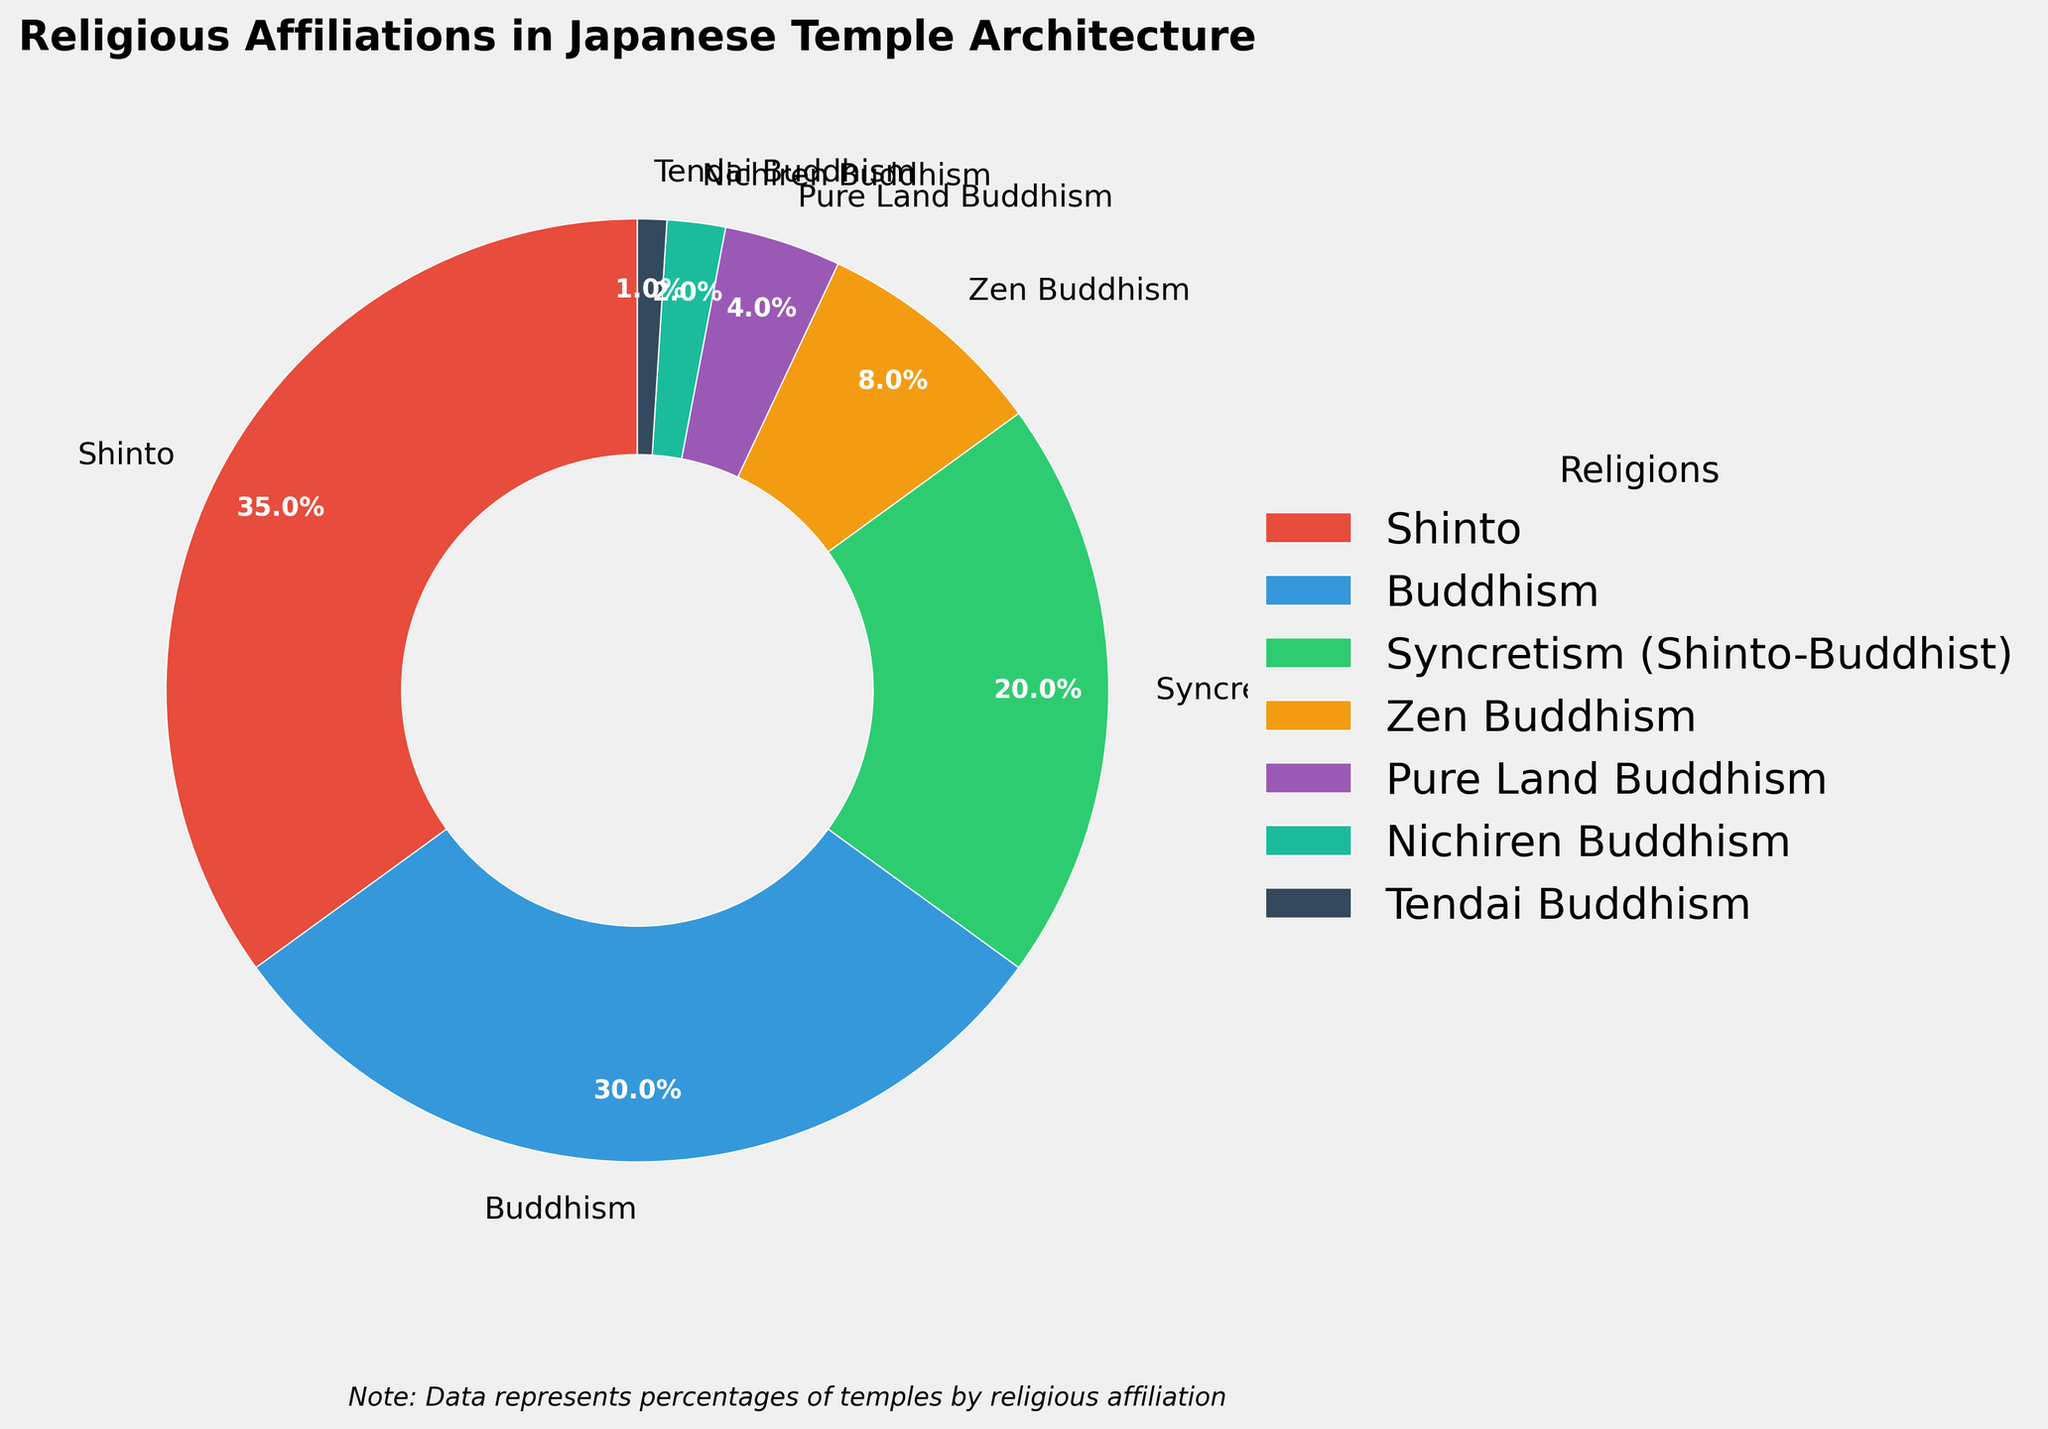How many religions have a representation greater than 20%? The figure shows the percentages for each religion. Shinto has 35%, Buddhism has 30%, and Syncretism (Shinto-Buddhist) has 20%. Only Shinto and Buddhism have representations greater than 20%.
Answer: 2 What is the combined percentage of Nichiren Buddhism and Tendai Buddhism? Nichiren Buddhism represents 2% and Tendai Buddhism represents 1%. Adding these two percentages together gives 2% + 1% = 3%.
Answer: 3% Which religious affiliation has the most significant representation in Japanese temple architecture? The figure shows the percentages for each religion. Shinto has the highest percentage at 35%.
Answer: Shinto How does the representation of Zen Buddhism compare to Pure Land Buddhism? The pie chart shows that Zen Buddhism is represented by 8% and Pure Land Buddhism by 4%. Zen Buddhism has a higher representation.
Answer: Zen Buddhism has a higher representation What is the smallest percentage depicted, and which religion does it represent? The figure shows that Tendai Buddhism has the smallest percentage at 1%.
Answer: Tendai Buddhism, 1% What is the difference in percentage between Shinto and Buddhism? Shinto is represented by 35% and Buddhism by 30%. The difference between them is 35% - 30% = 5%.
Answer: 5% Which religions fall under the combined term "Buddhism" in the chart? The pie chart shows several types of Buddhism: Buddhism (30%), Zen Buddhism (8%), Pure Land Buddhism (4%), Nichiren Buddhism (2%), and Tendai Buddhism (1%).
Answer: Buddhism, Zen Buddhism, Pure Land Buddhism, Nichiren Buddhism, Tendai Buddhism What percentage of the Japanese temple architecture is represented by forms of Buddhism, including Zen and others? Sum the percentages of all forms of Buddhism: 30% (Buddhism) + 8% (Zen Buddhism) + 4% (Pure Land Buddhism) + 2% (Nichiren Buddhism) + 1% (Tendai Buddhism) = 45%.
Answer: 45% Which segment is colored green in the pie chart, and what percentage does it represent? The green color represents Syncretism (Shinto-Buddhist), which accounts for 20% of the total.
Answer: Syncretism (Shinto-Buddhist), 20% How many religions have less than a 10% representation? The religions with less than 10% representation are Zen Buddhism (8%), Pure Land Buddhism (4%), Nichiren Buddhism (2%), and Tendai Buddhism (1%). Therefore, there are 4 religions.
Answer: 4 